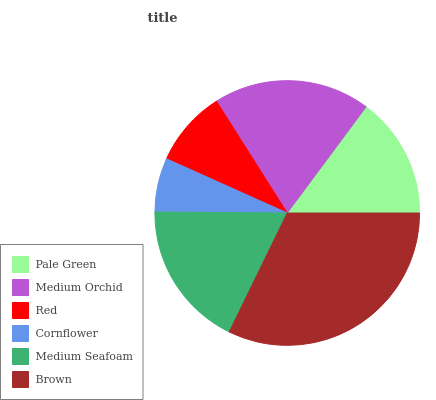Is Cornflower the minimum?
Answer yes or no. Yes. Is Brown the maximum?
Answer yes or no. Yes. Is Medium Orchid the minimum?
Answer yes or no. No. Is Medium Orchid the maximum?
Answer yes or no. No. Is Medium Orchid greater than Pale Green?
Answer yes or no. Yes. Is Pale Green less than Medium Orchid?
Answer yes or no. Yes. Is Pale Green greater than Medium Orchid?
Answer yes or no. No. Is Medium Orchid less than Pale Green?
Answer yes or no. No. Is Medium Seafoam the high median?
Answer yes or no. Yes. Is Pale Green the low median?
Answer yes or no. Yes. Is Brown the high median?
Answer yes or no. No. Is Brown the low median?
Answer yes or no. No. 